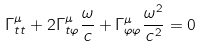Convert formula to latex. <formula><loc_0><loc_0><loc_500><loc_500>\Gamma ^ { \mu } _ { t t } + 2 \Gamma ^ { \mu } _ { t \varphi } \frac { \omega } { c } + \Gamma ^ { \mu } _ { \varphi \varphi } \frac { \omega ^ { 2 } } { c ^ { 2 } } = 0</formula> 